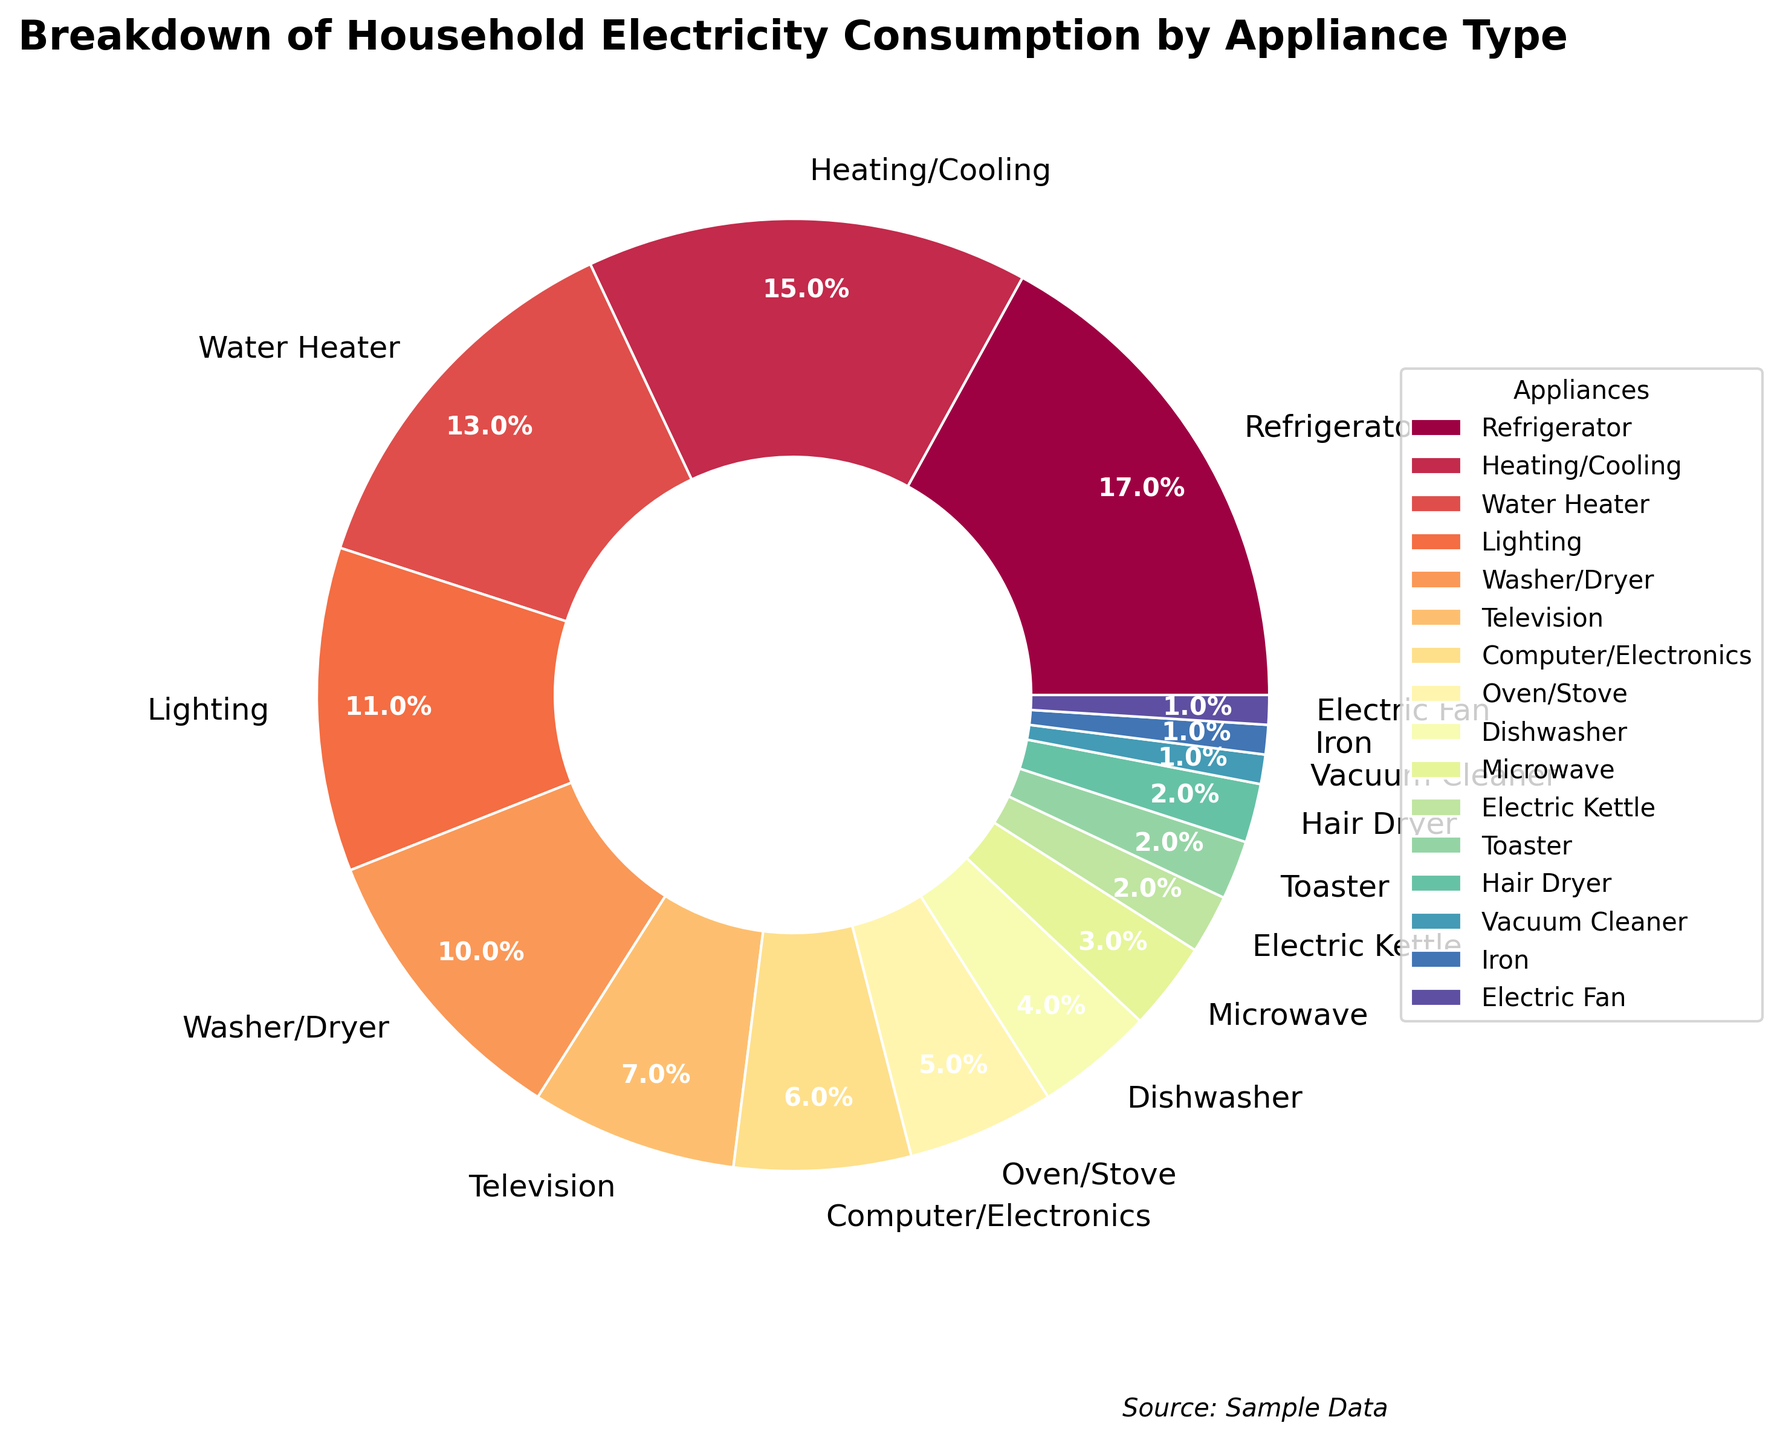What percentage of household electricity consumption is used by appliances other than the refrigerator? The refrigerator accounts for 17% of the consumption. To find the percentage for other appliances, subtract 17 from 100. 100% - 17% = 83%
Answer: 83% Which appliance consumes more electricity, the television or the oven/stove? The television consumes 7% while the oven/stove consumes 5%. Since 7% > 5%, the television consumes more electricity.
Answer: Television What is the combined electricity consumption percentage for heating/cooling and the water heater? Heating/cooling accounts for 15% and the water heater accounts for 13%. Adding these together: 15% + 13% = 28%
Answer: 28% Which appliances consume the least and most electricity in the household? The appliances that consume the least electricity are the vacuum cleaner, iron, and electric fan at 1% each. The appliance that consumes the most electricity is the refrigerator at 17%.
Answer: Least: Vacuum Cleaner, Iron, Electric Fan; Most: Refrigerator How much more electricity is used by the washer/dryer compared to the electric kettle? The washer/dryer consumes 10% while the electric kettle consumes 2%. The difference is 10% - 2% = 8%
Answer: 8% What's the total electricity consumption percentage for lighting, dishwasher, and microwave? Lighting accounts for 11%, the dishwasher for 4%, and the microwave for 3%. Adding these together: 11% + 4% + 3% = 18%
Answer: 18% Is the percentage of electricity consumed by the computer/electronics higher than by the hair dryer? The computer/electronics consume 6%, while the hair dryer consumes 2%. Since 6% is greater than 2%, the computer/electronics consume more electricity.
Answer: Yes If the remaining appliances consume 19% of the household electricity, what percentage is consumed by the washer/dryer and water heater? The total household electricity consumption is 100%. The remaining appliances account for 19%. Subtracting this from 100%: 100% - 19% = 81%. Out of this, the washer/dryer and water heater consume 10% and 13% respectively. Adding these: 10% + 13% = 23%
Answer: 23% 